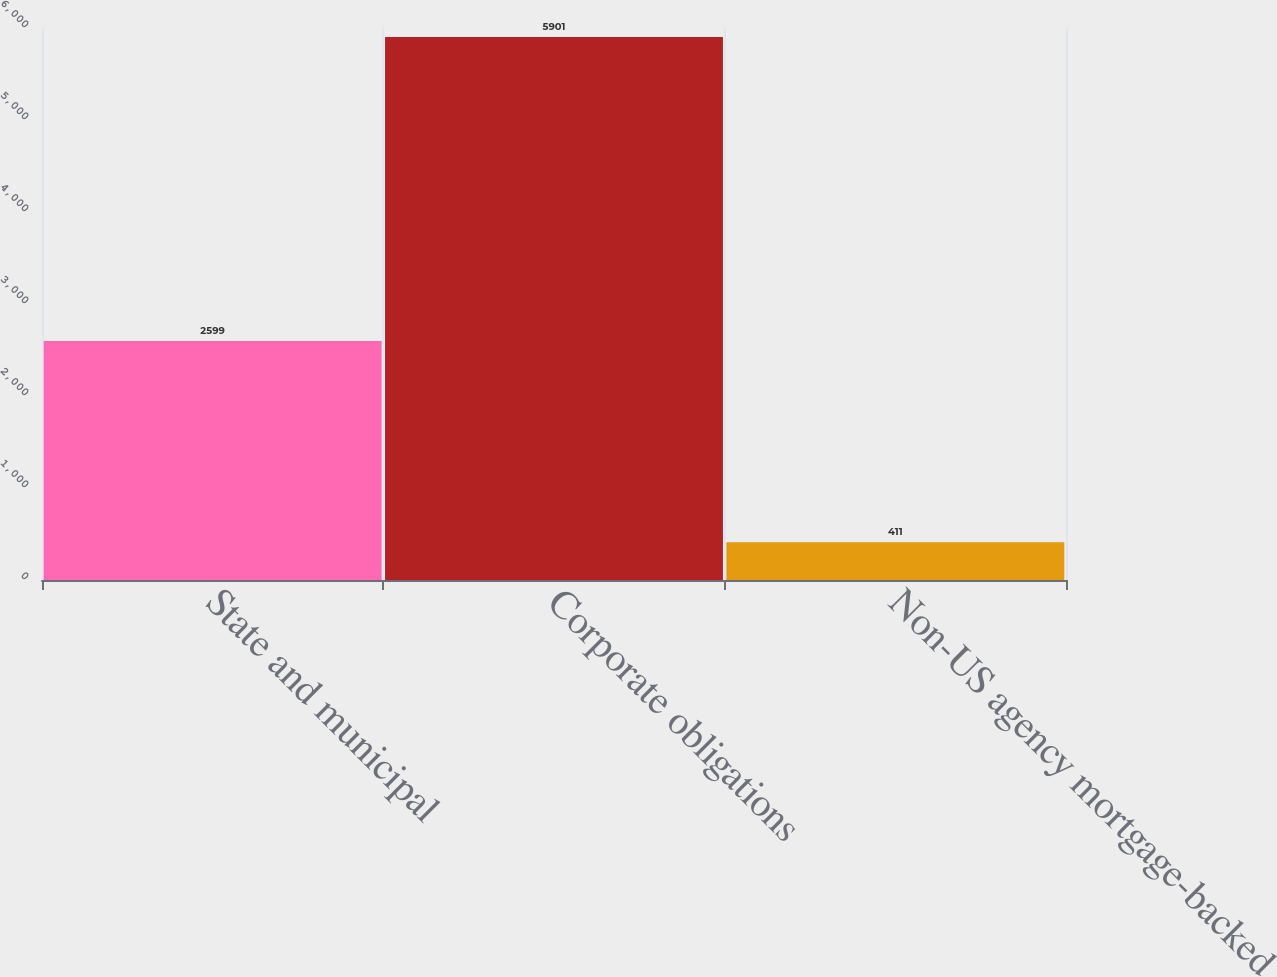Convert chart. <chart><loc_0><loc_0><loc_500><loc_500><bar_chart><fcel>State and municipal<fcel>Corporate obligations<fcel>Non-US agency mortgage-backed<nl><fcel>2599<fcel>5901<fcel>411<nl></chart> 